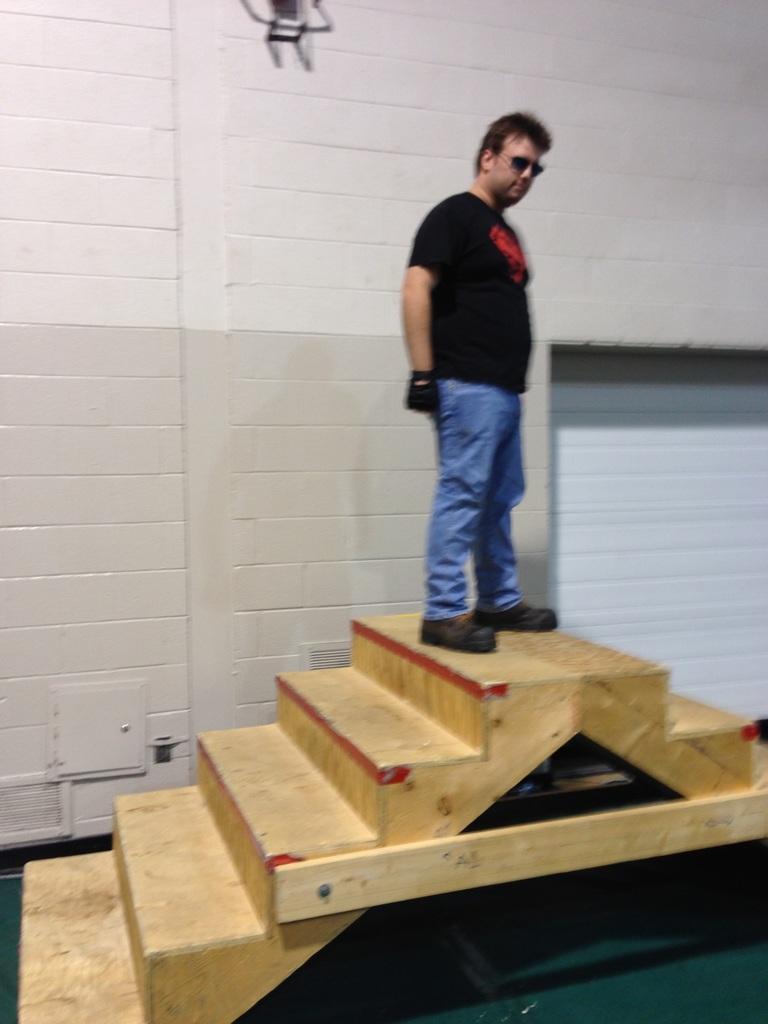Can you describe this image briefly? In this image we can see a person wearing black color T-shirt, shoes, gloves and blue color pant standing on stairs which are made of wood and in the background of the image there is a wall. 